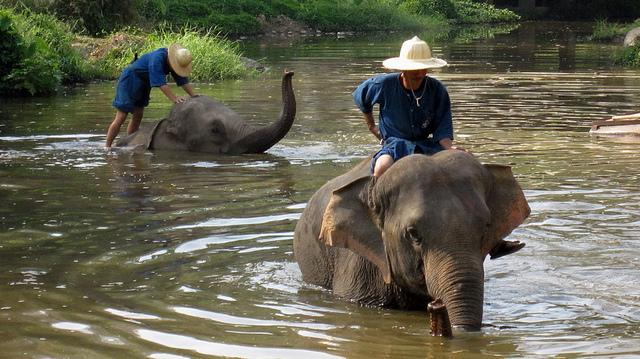What are the hats the men are wearing called? Please explain your reasoning. safari hats. The men would wear these to go on a safari. 